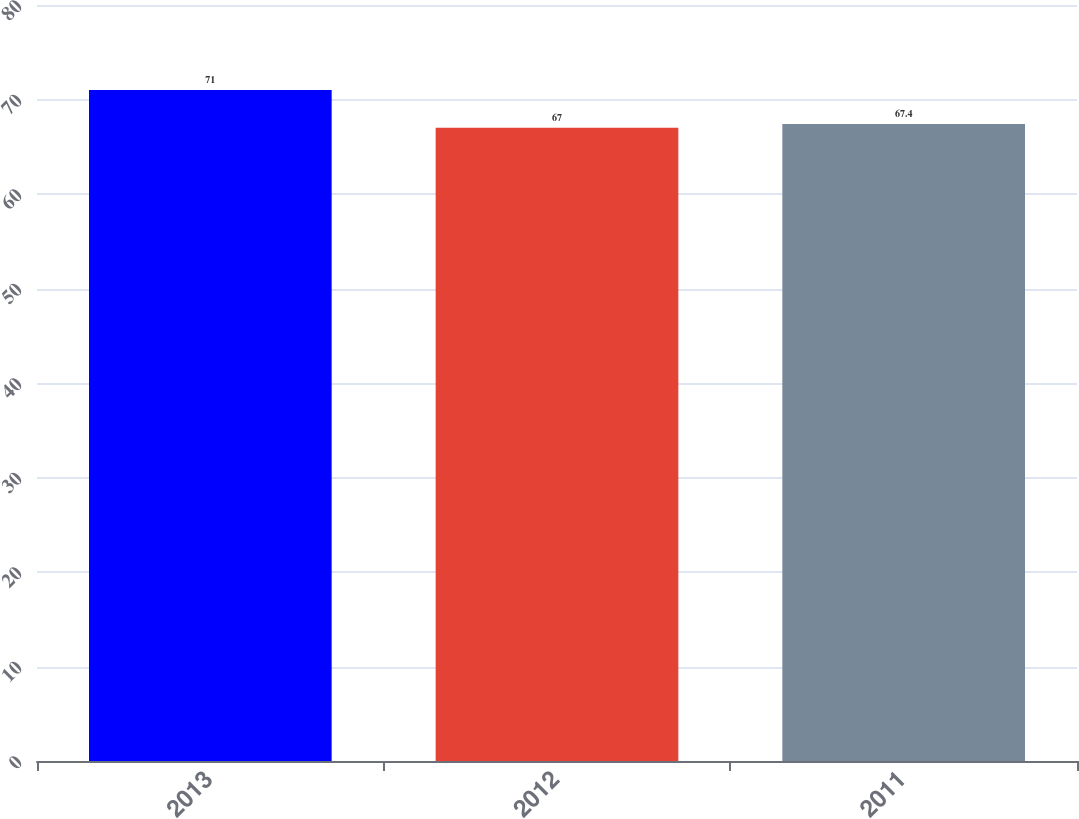<chart> <loc_0><loc_0><loc_500><loc_500><bar_chart><fcel>2013<fcel>2012<fcel>2011<nl><fcel>71<fcel>67<fcel>67.4<nl></chart> 